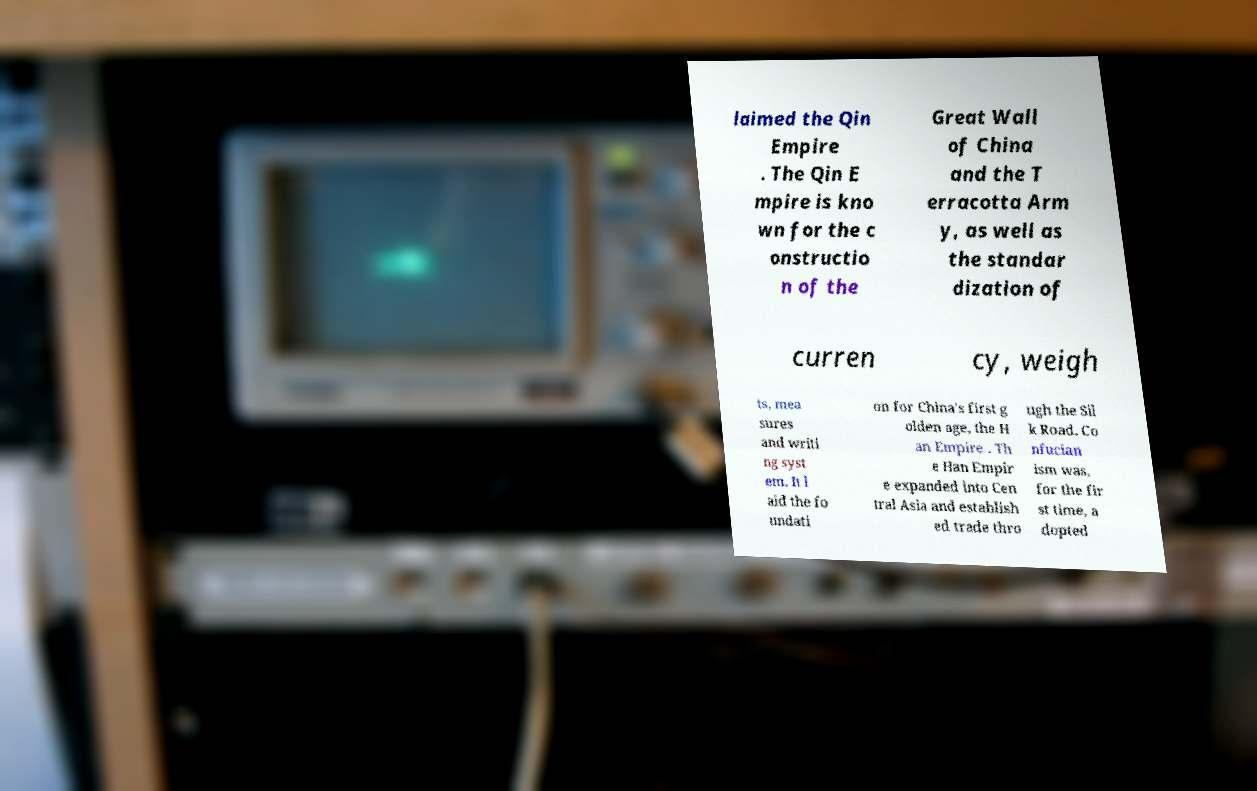I need the written content from this picture converted into text. Can you do that? laimed the Qin Empire . The Qin E mpire is kno wn for the c onstructio n of the Great Wall of China and the T erracotta Arm y, as well as the standar dization of curren cy, weigh ts, mea sures and writi ng syst em. It l aid the fo undati on for China's first g olden age, the H an Empire . Th e Han Empir e expanded into Cen tral Asia and establish ed trade thro ugh the Sil k Road. Co nfucian ism was, for the fir st time, a dopted 